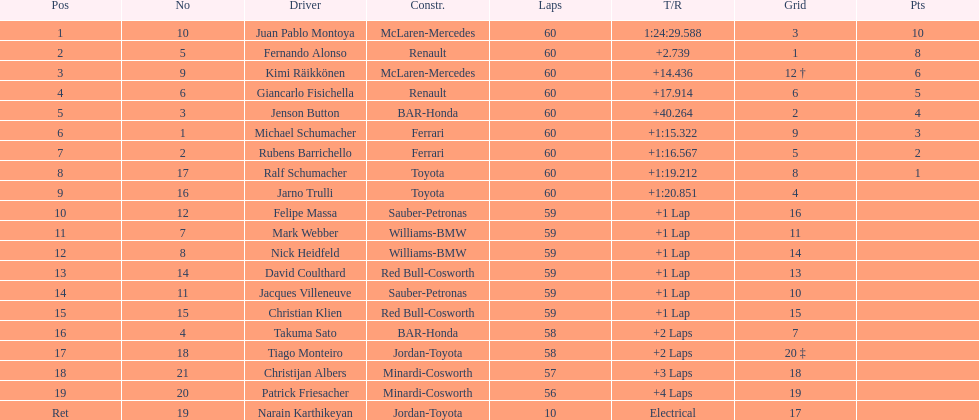Is there a points difference between the 9th position and 19th position on the list? No. 